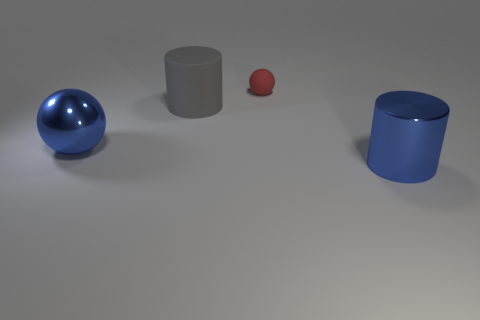Add 1 tiny red matte spheres. How many objects exist? 5 Subtract all big metallic cylinders. Subtract all big gray cylinders. How many objects are left? 2 Add 1 large metallic spheres. How many large metallic spheres are left? 2 Add 3 big blue shiny cylinders. How many big blue shiny cylinders exist? 4 Subtract 0 yellow blocks. How many objects are left? 4 Subtract 2 balls. How many balls are left? 0 Subtract all yellow balls. Subtract all yellow cylinders. How many balls are left? 2 Subtract all purple blocks. How many red cylinders are left? 0 